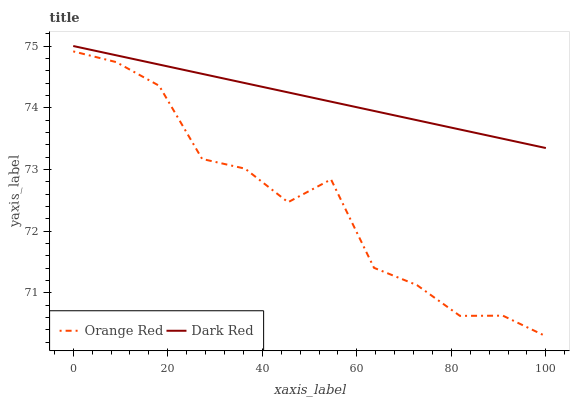Does Orange Red have the minimum area under the curve?
Answer yes or no. Yes. Does Dark Red have the maximum area under the curve?
Answer yes or no. Yes. Does Orange Red have the maximum area under the curve?
Answer yes or no. No. Is Dark Red the smoothest?
Answer yes or no. Yes. Is Orange Red the roughest?
Answer yes or no. Yes. Is Orange Red the smoothest?
Answer yes or no. No. Does Dark Red have the highest value?
Answer yes or no. Yes. Does Orange Red have the highest value?
Answer yes or no. No. Is Orange Red less than Dark Red?
Answer yes or no. Yes. Is Dark Red greater than Orange Red?
Answer yes or no. Yes. Does Orange Red intersect Dark Red?
Answer yes or no. No. 